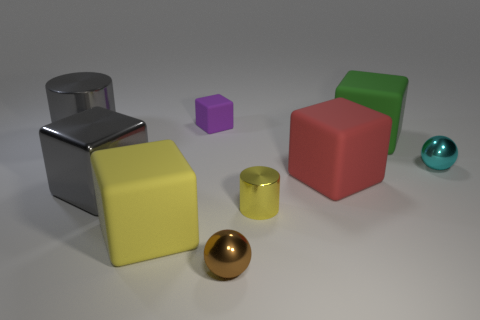Can you tell me the colors of the different objects in this image? Certainly! In the image, we have objects in several colors: there's a silver cylinder, a purple cube, an aqua sphere, a green cube, a red cube, a yellow cube, and lastly, a golden sphere.  Which of these objects are metallic? From the image, the objects with a metallic sheen are the silver cylinder and the golden sphere. They both reflect light in a way that suggests a metal-like material, giving them a lustrous, reflective quality. 